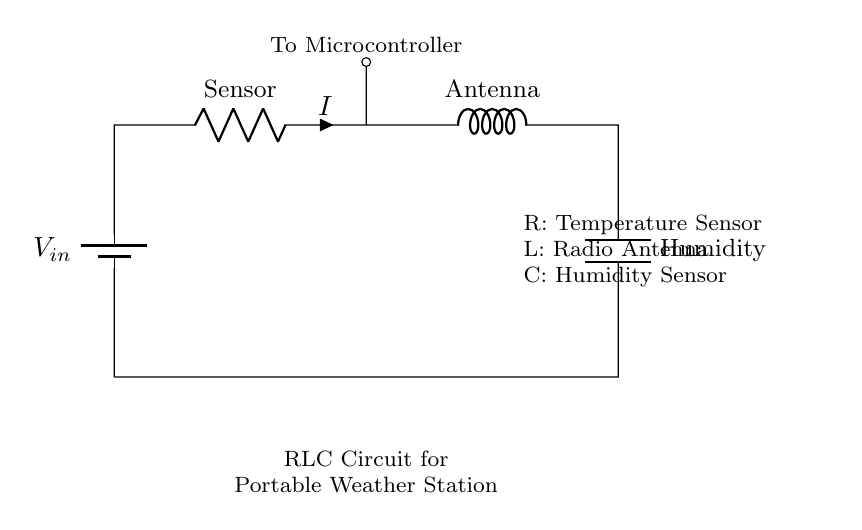What is the voltage source in this circuit? The circuit has a battery labeled as V_in which acts as the voltage source. The label indicates that it provides the necessary electrical potential for the circuit to function.
Answer: V_in What component represents the temperature sensor? In the circuit, the resistor (R) is labeled as "Sensor," indicating that it is the component associated with measuring temperature.
Answer: Sensor What component in the circuit is used for radio communication? The inductor (L) is labeled as "Antenna," which typically serves for radio frequencies and communication purposes in the circuit.
Answer: Antenna What is the purpose of the capacitor in this circuit? The capacitor (C) is labeled as "Humidity," which suggests it is used for monitoring humidity levels in the environment, helping in data collection for weather conditions.
Answer: Humidity What is the relationship between the components in this RLC circuit? In this RLC circuit, all components (resistor, inductor, and capacitor) are connected in series, meaning they work together to create a complete circuit for measuring atmospheric conditions. The interplay between these components allows the weather station to function effectively.
Answer: Series connection 